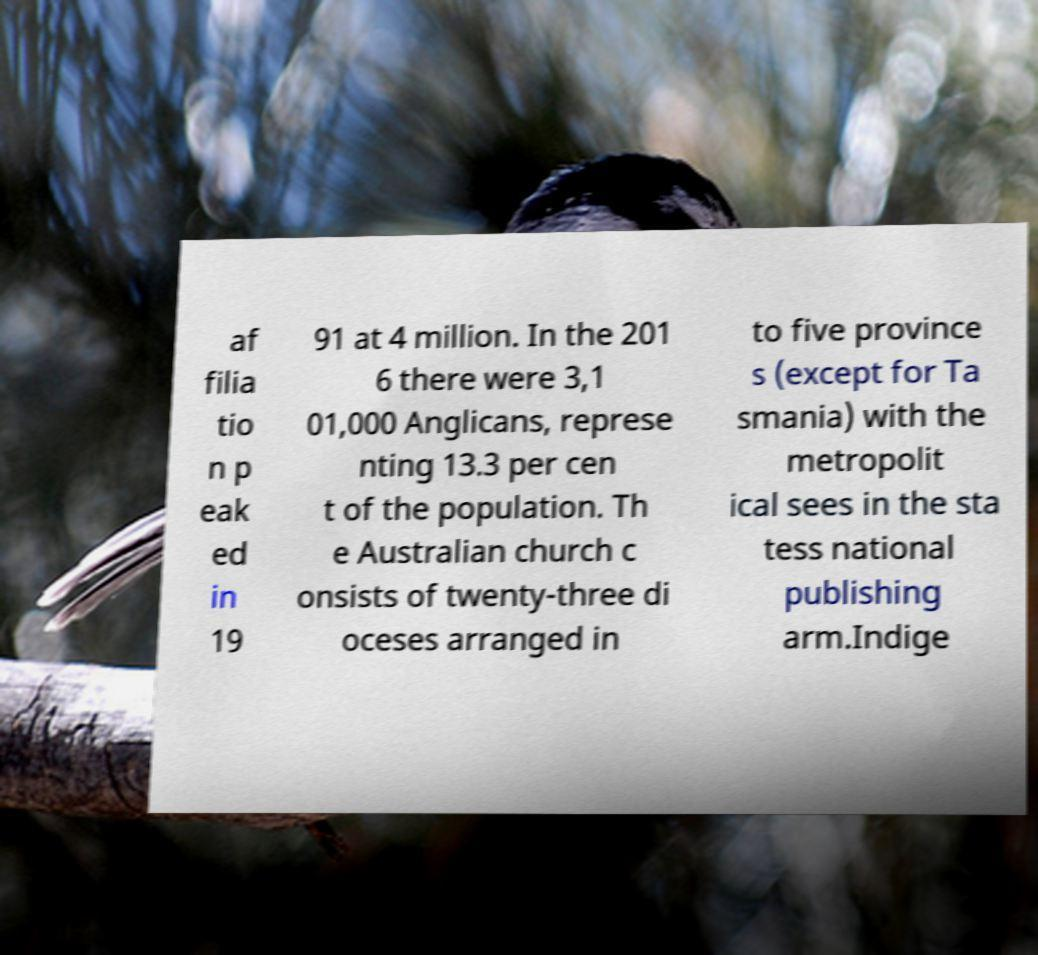I need the written content from this picture converted into text. Can you do that? af filia tio n p eak ed in 19 91 at 4 million. In the 201 6 there were 3,1 01,000 Anglicans, represe nting 13.3 per cen t of the population. Th e Australian church c onsists of twenty-three di oceses arranged in to five province s (except for Ta smania) with the metropolit ical sees in the sta tess national publishing arm.Indige 